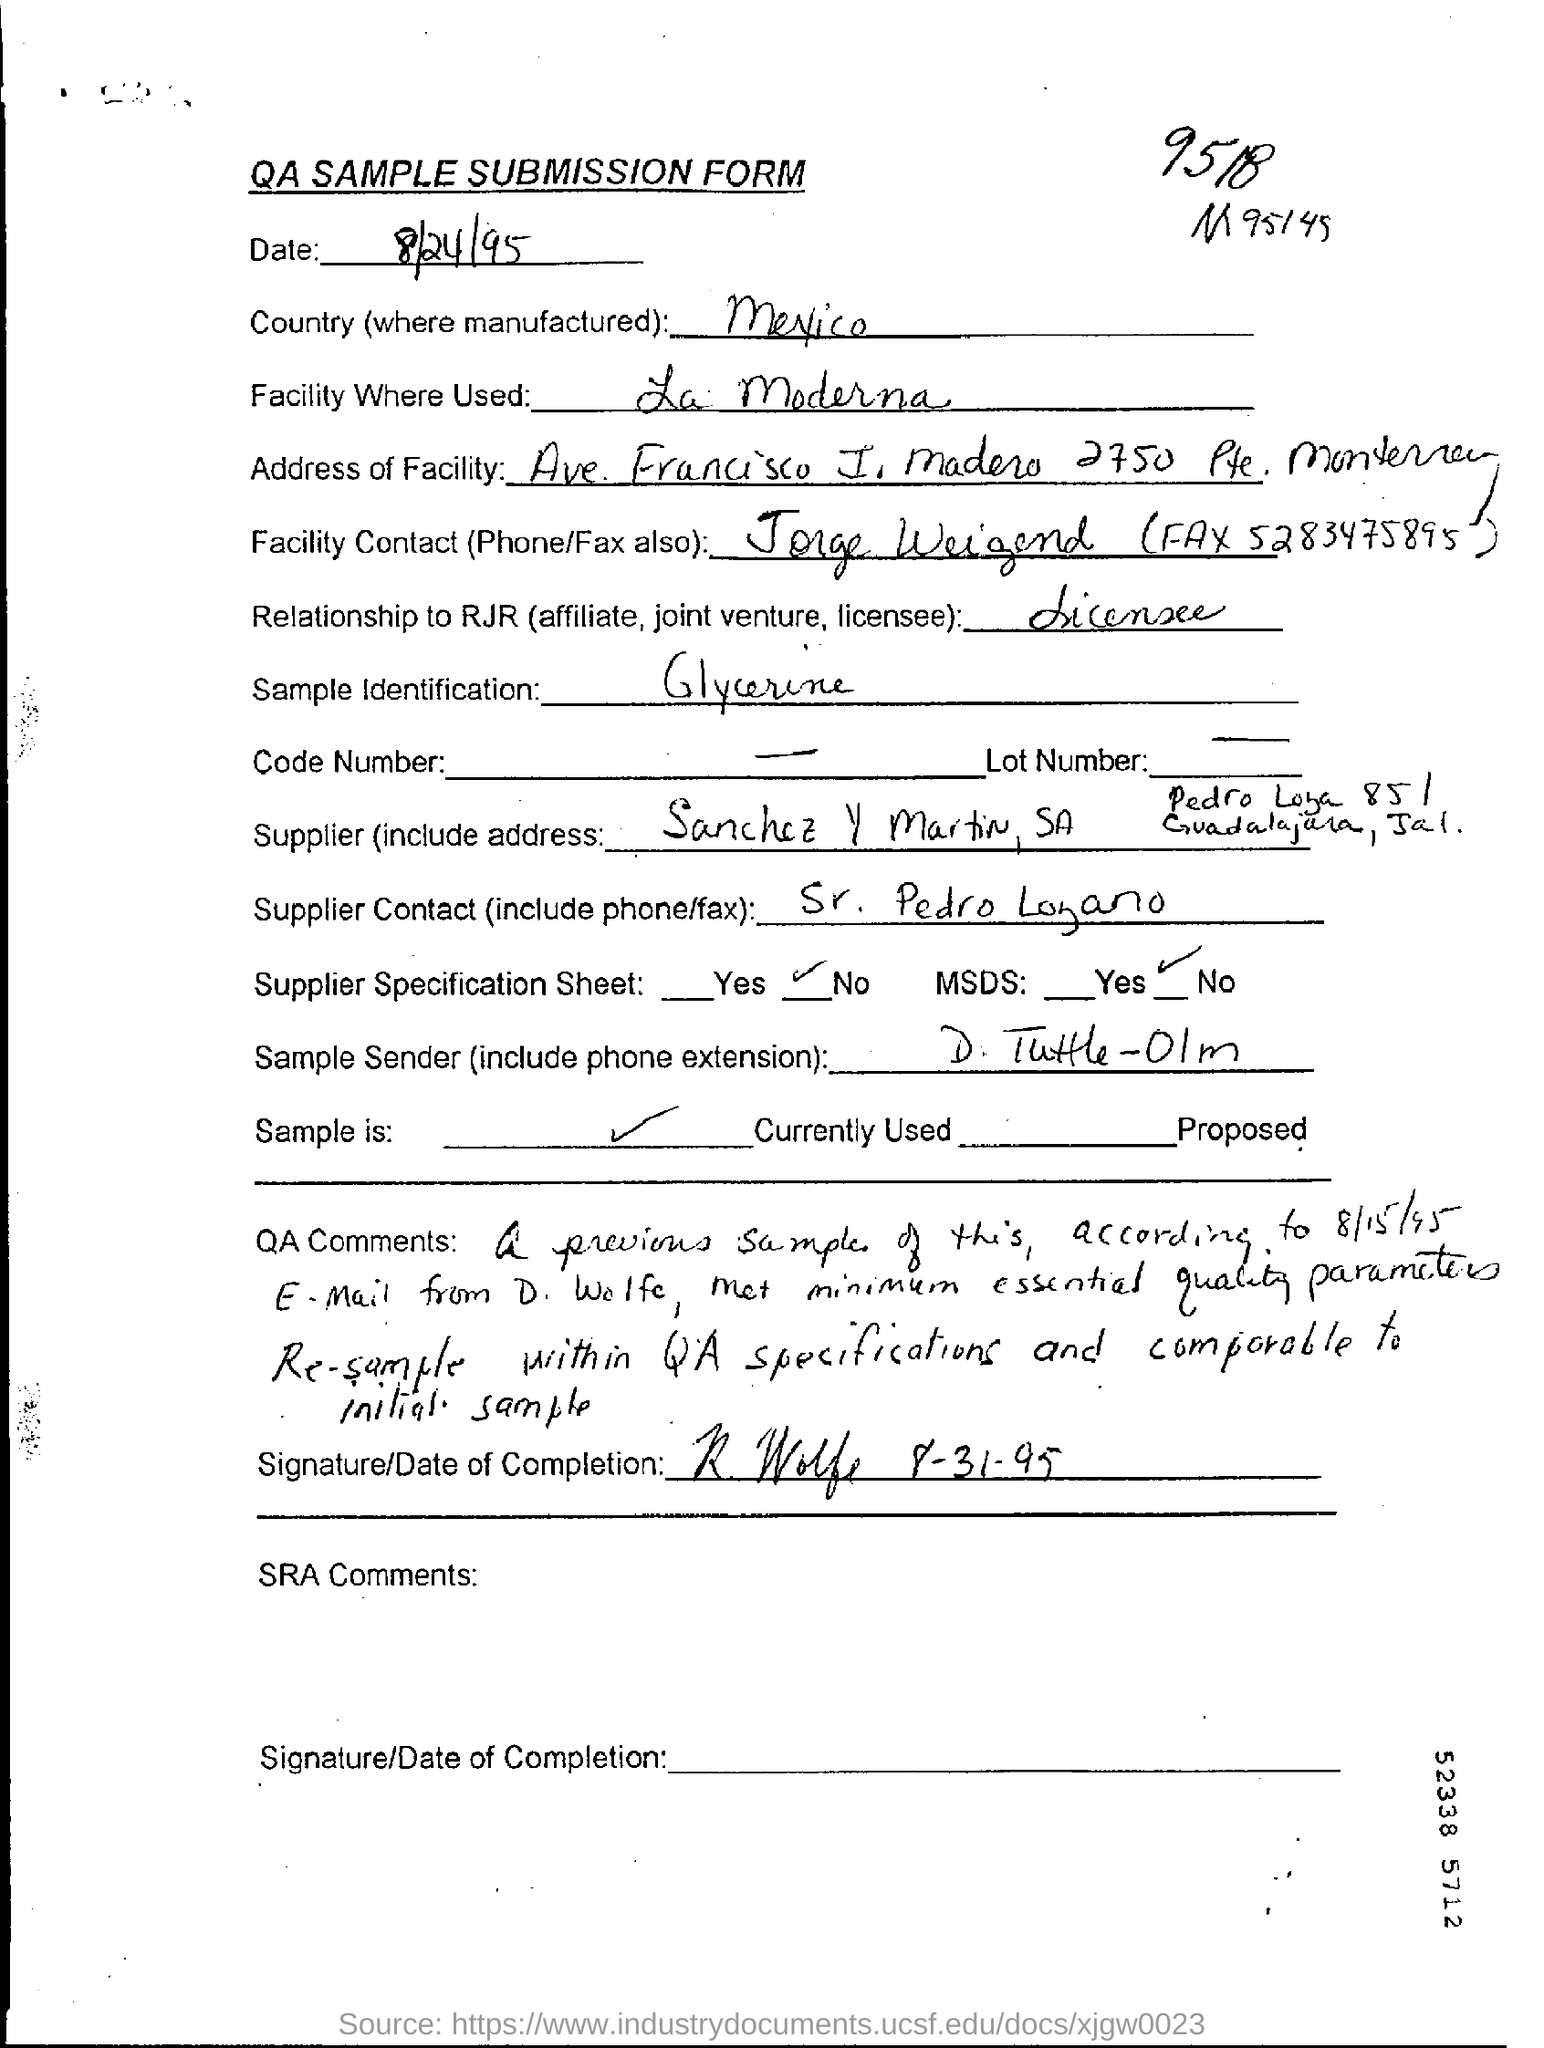What is the date of submission form?
Provide a short and direct response. 8/24/95. Name the country (where manufactured)?
Offer a very short reply. Mexico. What is the facility contact (phone/fax)?
Keep it short and to the point. Jorge  weigend (fax 5283475895). What is simpe identification?
Your answer should be very brief. Glycerine. 